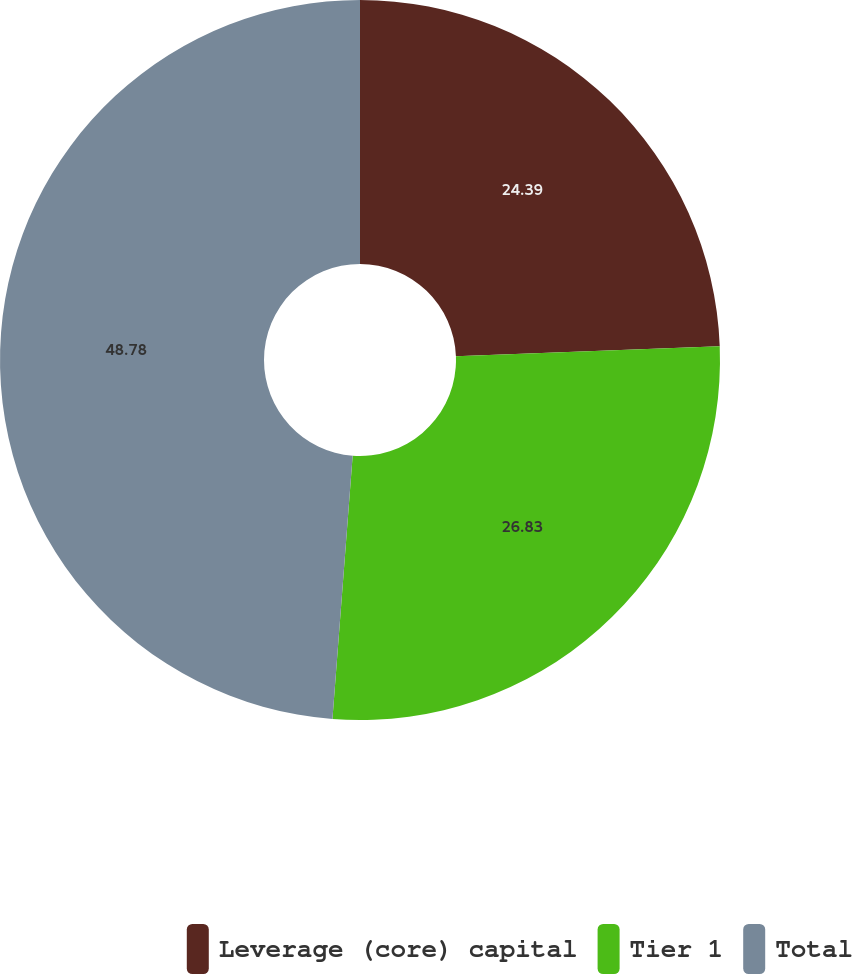Convert chart to OTSL. <chart><loc_0><loc_0><loc_500><loc_500><pie_chart><fcel>Leverage (core) capital<fcel>Tier 1<fcel>Total<nl><fcel>24.39%<fcel>26.83%<fcel>48.78%<nl></chart> 